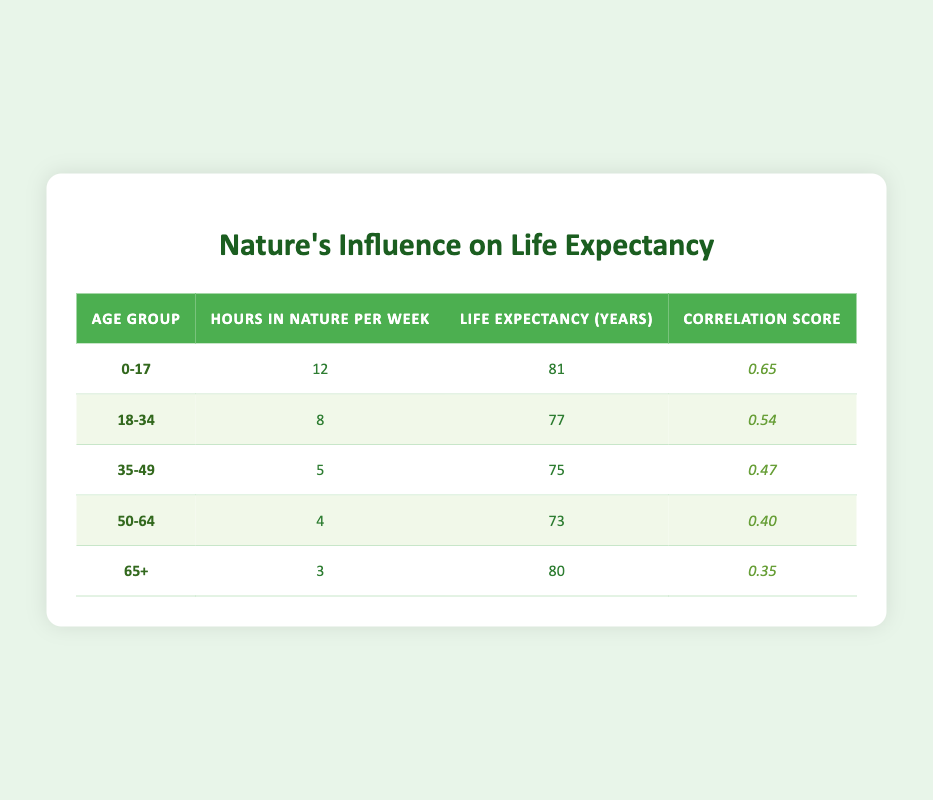What is the life expectancy for the age group 0-17? According to the table, the life expectancy for the age group 0-17 is listed as 81 years.
Answer: 81 How many hours do those aged 18-34 spend in nature per week? The table states that individuals aged 18-34 spend 8 hours in nature per week.
Answer: 8 What is the correlation score for the age group 50-64? The table shows that the correlation score for the age group 50-64 is 0.40.
Answer: 0.40 Which age group has the highest correlation score related to time spent in nature? By reviewing the correlation scores in the table, the age group 0-17 has the highest correlation score at 0.65.
Answer: 0-17 What is the average life expectancy among all age groups presented? To calculate the average life expectancy, we add the life expectancies: (81 + 77 + 75 + 73 + 80) = 386. Then we divide by the number of age groups (5), giving us 386 / 5 = 77.2.
Answer: 77.2 Is the life expectancy of the 65+ age group greater than that of the 35-49 age group? The table lists the life expectancy of the 65+ age group as 80 years, while the 35-49 age group's expectancy is 75 years. Since 80 is greater than 75, the statement is true.
Answer: Yes How does the life expectancy of the 50-64 age group compare to that of the 0-17 age group? The life expectancy for the 50-64 age group is 73 years, and for the 0-17 group, it is 81 years. Since 73 is less than 81, the life expectancy for the 50-64 group is lower.
Answer: Lower If the age group 18-34 increased their nature time by 2 hours, what would their new hours spent in nature be? Currently, the 18-34 age group spends 8 hours in nature per week. If they increase it by 2 hours, the new total would be 8 + 2 = 10 hours.
Answer: 10 What is the difference in life expectancy between the age groups 0-17 and 50-64? The life expectancy for the 0-17 age group is 81 years, while for the 50-64 age group it is 73 years. The difference is calculated as 81 - 73 = 8 years.
Answer: 8 